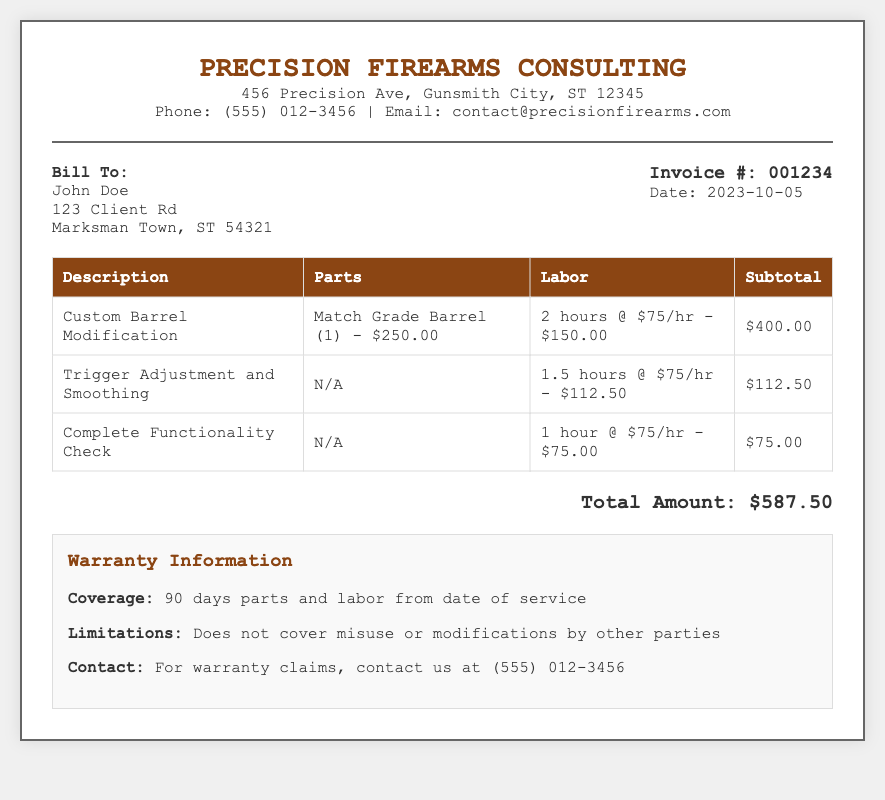What is the invoice number? The invoice number is stated in the invoice details section.
Answer: 001234 Who is the billed customer? The billed customer information is found in the Bill To section.
Answer: John Doe How much was charged for the custom barrel modification? The charge for the custom barrel modification can be found in the table under Subtotal.
Answer: $400.00 What is the total amount due? The total amount due is indicated at the bottom of the invoice.
Answer: $587.50 What is the warranty coverage duration? The warranty information specifies the coverage duration clearly.
Answer: 90 days How many hours of labor were billed for trigger adjustment? The labor hours for trigger adjustment can be found in the labor column of the invoice.
Answer: 1.5 hours What type of barrel was modified? The type of barrel modification is listed in the description section of the invoice.
Answer: Match Grade Barrel What is the rate for labor per hour? The labor rate is mentioned in the context of various labor charges throughout the document.
Answer: $75/hr What is the limitation regarding the warranty? The warranty section explains the limitations clearly.
Answer: Misuse or modifications by other parties 